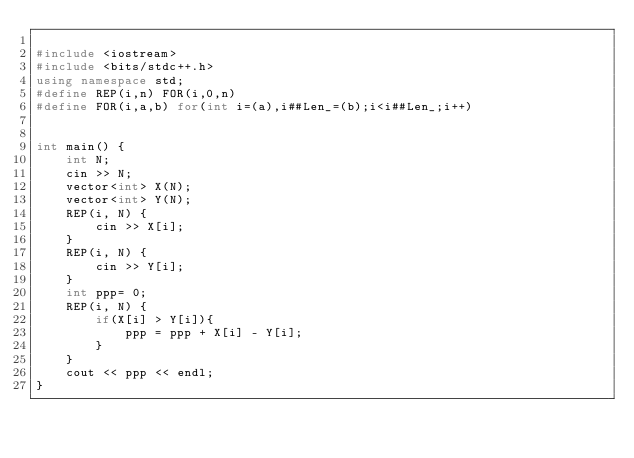Convert code to text. <code><loc_0><loc_0><loc_500><loc_500><_C++_>
#include <iostream>
#include <bits/stdc++.h>
using namespace std;
#define REP(i,n) FOR(i,0,n)
#define FOR(i,a,b) for(int i=(a),i##Len_=(b);i<i##Len_;i++)


int main() {
    int N;
    cin >> N;
    vector<int> X(N);
    vector<int> Y(N);
    REP(i, N) {
        cin >> X[i];
    }
    REP(i, N) {
        cin >> Y[i];
    }
    int ppp= 0;
    REP(i, N) {
        if(X[i] > Y[i]){
            ppp = ppp + X[i] - Y[i];       
        } 
    }
    cout << ppp << endl;
}

</code> 